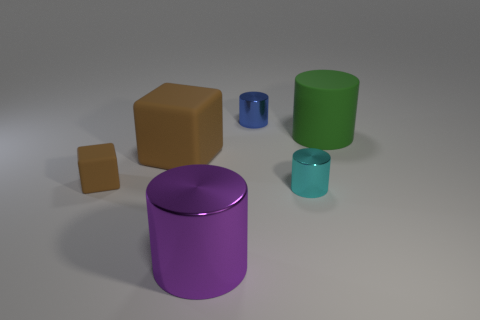Are there any large cylinders to the right of the blue thing?
Keep it short and to the point. Yes. Are the block that is to the right of the small brown rubber cube and the small brown cube made of the same material?
Offer a very short reply. Yes. There is a big matte thing to the right of the cylinder in front of the tiny cyan cylinder; are there any cylinders in front of it?
Provide a short and direct response. Yes. What number of cubes are either tiny blue metal things or brown things?
Give a very brief answer. 2. What material is the small cylinder behind the tiny brown thing?
Give a very brief answer. Metal. There is another matte cube that is the same color as the tiny cube; what size is it?
Give a very brief answer. Large. Is the color of the small thing that is to the left of the purple metallic object the same as the large rubber object on the left side of the small blue shiny cylinder?
Ensure brevity in your answer.  Yes. What number of things are either metallic cylinders or green metallic cylinders?
Offer a very short reply. 3. How many other things are the same shape as the tiny matte object?
Keep it short and to the point. 1. Does the large cylinder that is to the right of the purple object have the same material as the small object behind the green rubber cylinder?
Ensure brevity in your answer.  No. 